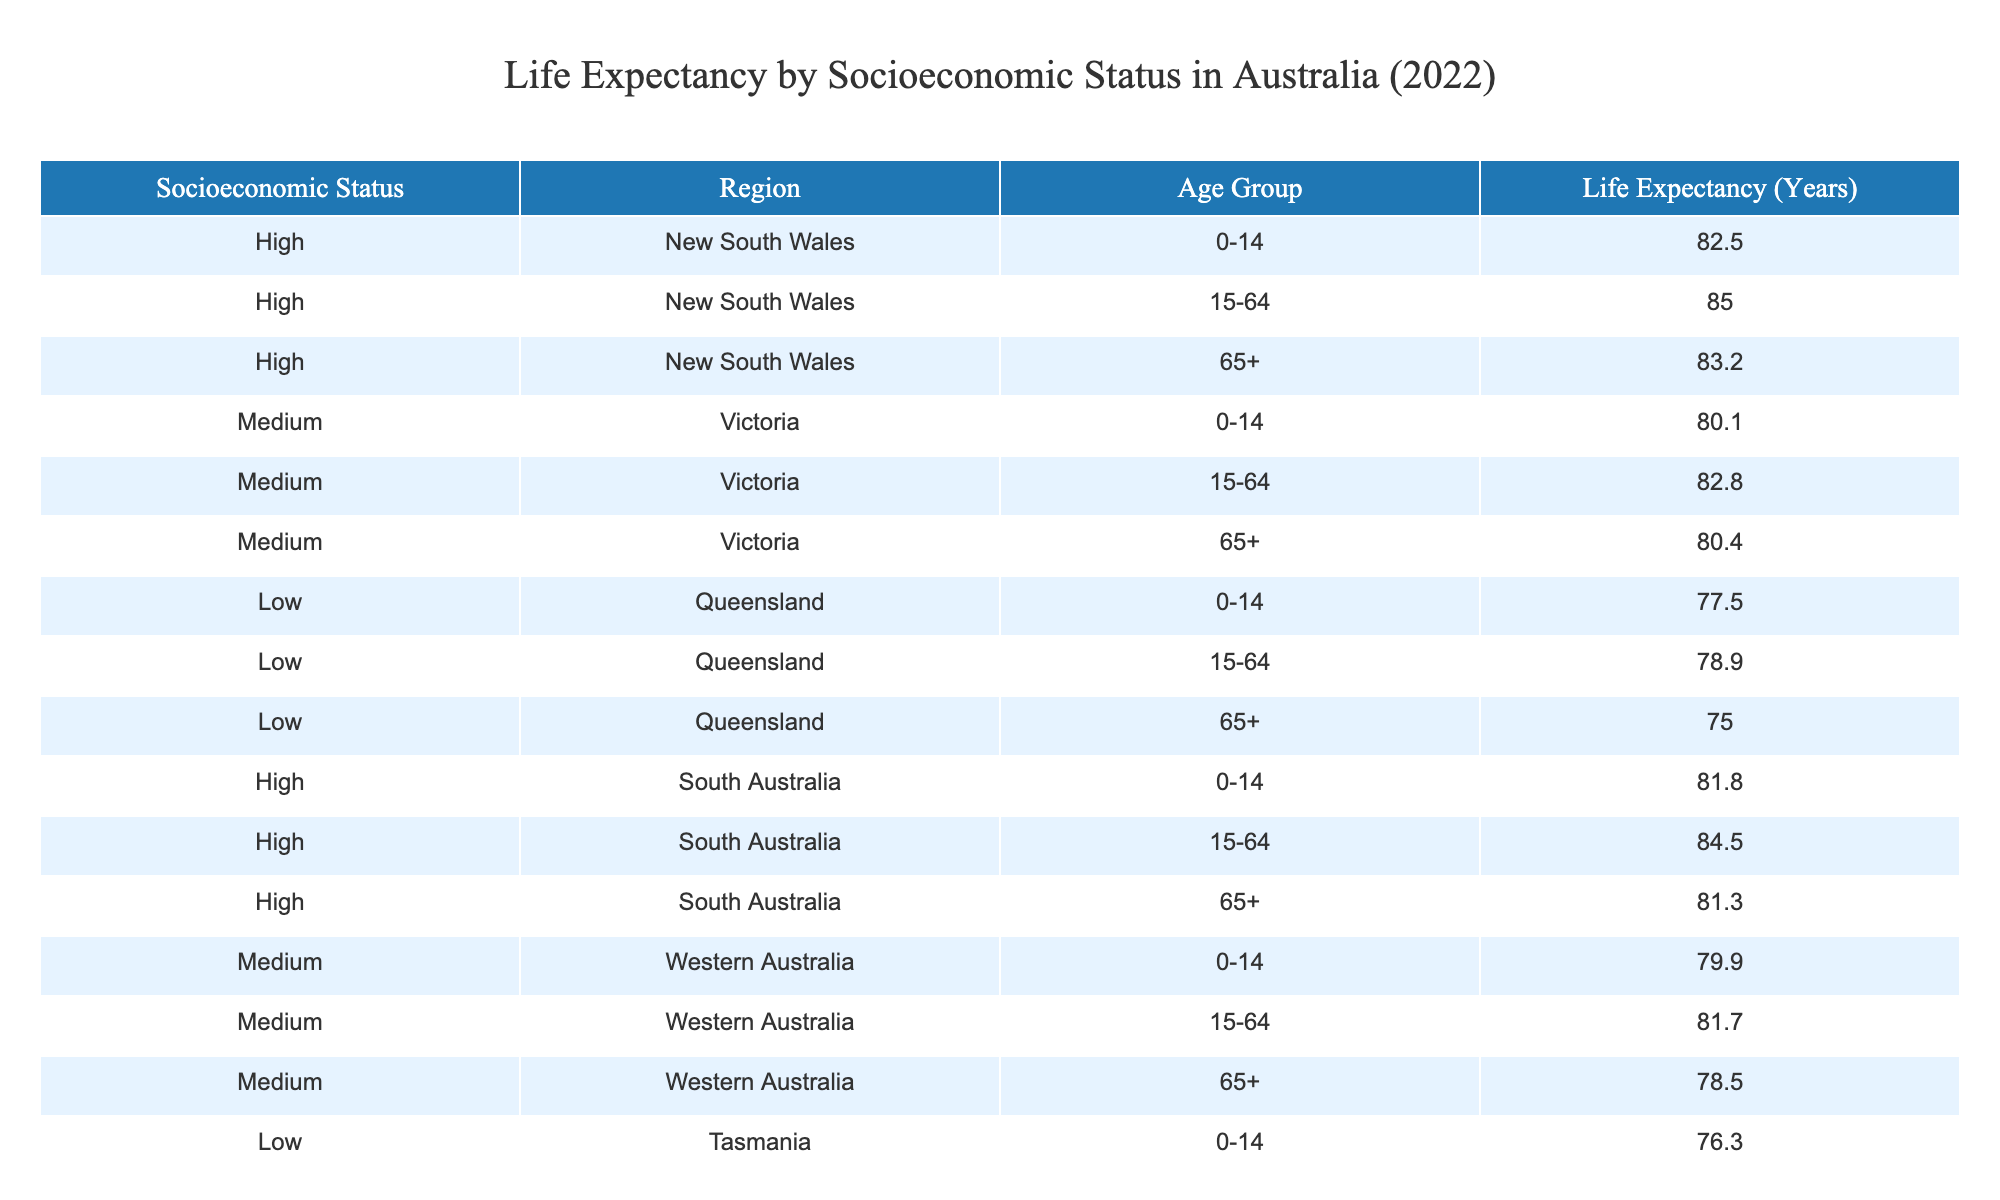What is the life expectancy for individuals aged 0-14 in high socioeconomic regions? Referring to the table, the life expectancy for the 0-14 age group in high socioeconomic regions, specifically New South Wales, South Australia, and the average across these regions, is listed as 82.5 years for NSW and 81.8 years for SA. The highest value is 82.5 years in NSW.
Answer: 82.5 years What is the life expectancy for the age group 65+ in low socioeconomic status regions? Looking at the table, for the low socioeconomic status regions, the life expectancy for those aged 65+ in Queensland and Tasmania is 75.0 years and 74.2 years, respectively. The lower of the two is 74.2 years in Tasmania.
Answer: 74.2 years Which region has the highest life expectancy for the age group 15-64? The table shows the life expectancies for the 15-64 age group across different regions. New South Wales has a life expectancy of 85.0 years, while other regions like Victoria and South Australia show lower values (82.8 and 84.5 years, respectively). Thus, NSW has the highest value.
Answer: New South Wales What is the average life expectancy for the 15-64 age group across all socioeconomic statuses? Calculating the average involves summing the life expectancies for the 15-64 age group in each region: 85.0 (NSW) + 82.8 (Victoria) + 78.9 (Queensland) + 84.5 (South Australia) + 81.7 (Western Australia) + 77.4 (Tasmania) = 490.3 years. Dividing by the number of regions (6), the average is 490.3 / 6 = 81.72 years.
Answer: 81.72 years Is the life expectancy for the 65+ age group in medium socioeconomic regions higher than in low socioeconomic regions? In the medium socioeconomic regions, Western Australia shows a life expectancy of 78.5 years for the 65+ age group, whereas in low socioeconomic regions, Queensland shows 75.0 years and Tasmania 74.2 years. Since 78.5 is greater than both, the answer is yes.
Answer: Yes Which region shows the lowest life expectancy for individuals aged 0-14? Checking the table, Tasmania has the lowest life expectancy for those aged 0-14 at 76.3 years compared to Queensland (77.5 years) and other regions.
Answer: Tasmania What is the difference in life expectancy between the high and low socioeconomic regions for the age group 65+? The life expectancy for the 65+ age group in high socioeconomic regions averages (83.2 in NSW + 81.3 in SA) / 2 = 82.25 years. In low socioeconomic regions, the average is (75.0 in Queensland + 74.2 in Tasmania) / 2 = 74.6 years. The difference is 82.25 - 74.6 = 7.65 years.
Answer: 7.65 years Are individuals in high socioeconomic regions more likely to live longer compared to those in low socioeconomic regions across all age groups? Examining each age group's life expectancy, high socioeconomic regions have averages of 82.5 (0-14), 85.0 (15-64), and 83.2 (65+) years, while low socioeconomic averages are 77.5 (0-14), 78.9 (15-64), and 75.0 (65+). All high values exceed low values; thus, the answer is yes.
Answer: Yes 